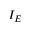<formula> <loc_0><loc_0><loc_500><loc_500>I _ { E }</formula> 